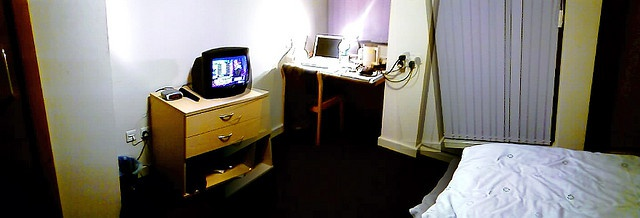Describe the objects in this image and their specific colors. I can see bed in black, lavender, and darkgray tones, tv in black, white, navy, and darkgray tones, chair in black, maroon, and brown tones, laptop in black, white, darkgray, and gray tones, and clock in black, darkgray, gray, and maroon tones in this image. 